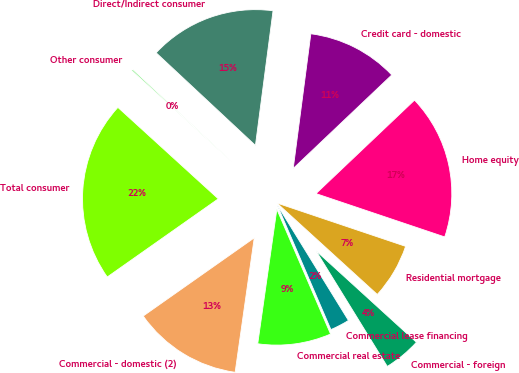<chart> <loc_0><loc_0><loc_500><loc_500><pie_chart><fcel>Residential mortgage<fcel>Home equity<fcel>Credit card - domestic<fcel>Direct/Indirect consumer<fcel>Other consumer<fcel>Total consumer<fcel>Commercial - domestic (2)<fcel>Commercial real estate<fcel>Commercial lease financing<fcel>Commercial - foreign<nl><fcel>6.59%<fcel>17.25%<fcel>10.85%<fcel>15.12%<fcel>0.19%<fcel>21.52%<fcel>12.99%<fcel>8.72%<fcel>2.32%<fcel>4.45%<nl></chart> 